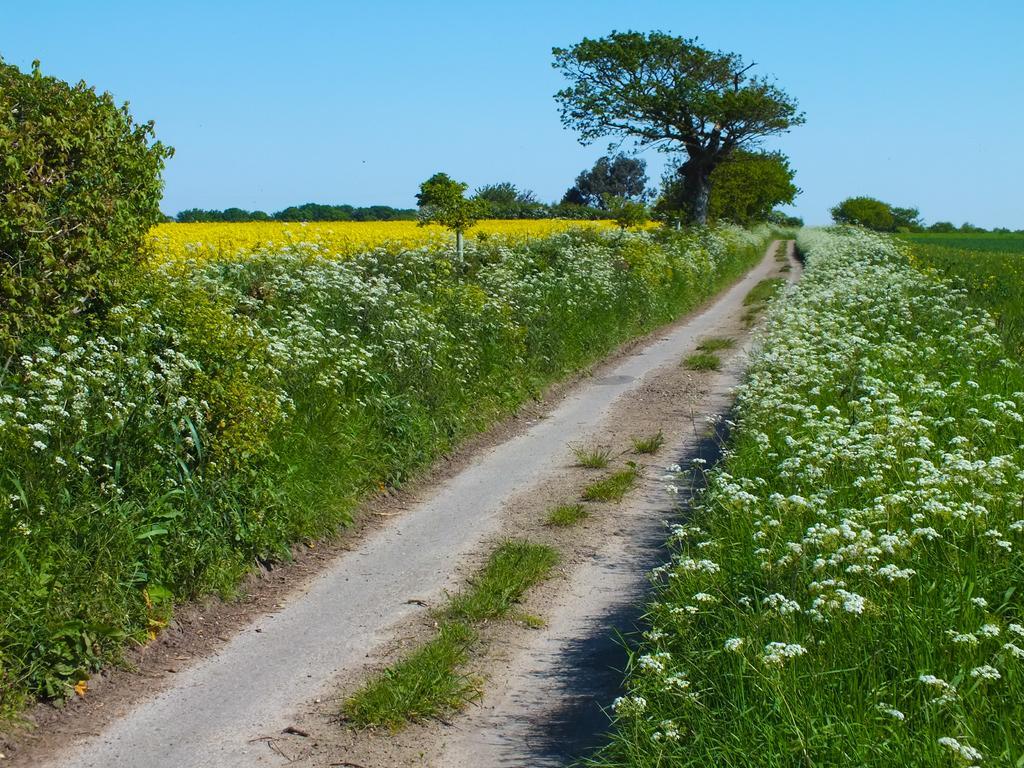Can you describe this image briefly? In the center of the image we can see some plants, flowers, trees. At the bottom of the image we can see road, grass. At the top of the image we can see the sky. 